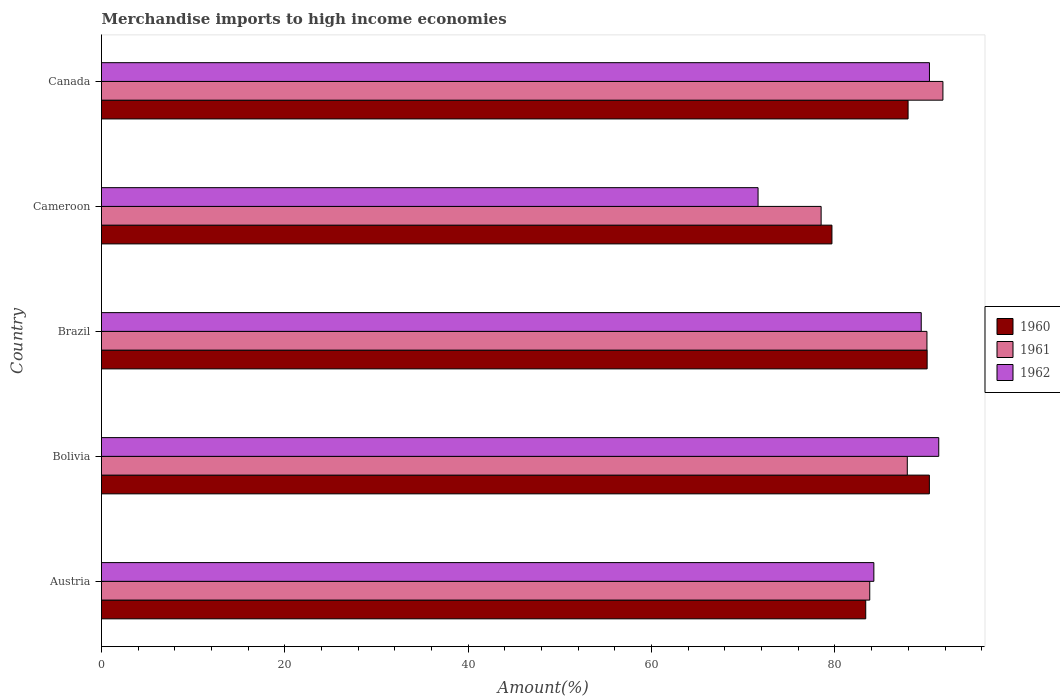How many bars are there on the 1st tick from the top?
Offer a terse response. 3. How many bars are there on the 4th tick from the bottom?
Provide a short and direct response. 3. What is the label of the 2nd group of bars from the top?
Provide a succinct answer. Cameroon. In how many cases, is the number of bars for a given country not equal to the number of legend labels?
Provide a short and direct response. 0. What is the percentage of amount earned from merchandise imports in 1962 in Canada?
Keep it short and to the point. 90.3. Across all countries, what is the maximum percentage of amount earned from merchandise imports in 1962?
Give a very brief answer. 91.32. Across all countries, what is the minimum percentage of amount earned from merchandise imports in 1961?
Offer a very short reply. 78.49. In which country was the percentage of amount earned from merchandise imports in 1962 maximum?
Offer a very short reply. Bolivia. In which country was the percentage of amount earned from merchandise imports in 1961 minimum?
Give a very brief answer. Cameroon. What is the total percentage of amount earned from merchandise imports in 1960 in the graph?
Ensure brevity in your answer.  431.34. What is the difference between the percentage of amount earned from merchandise imports in 1961 in Austria and that in Canada?
Your answer should be compact. -7.98. What is the difference between the percentage of amount earned from merchandise imports in 1960 in Bolivia and the percentage of amount earned from merchandise imports in 1961 in Austria?
Offer a very short reply. 6.5. What is the average percentage of amount earned from merchandise imports in 1962 per country?
Give a very brief answer. 85.38. What is the difference between the percentage of amount earned from merchandise imports in 1960 and percentage of amount earned from merchandise imports in 1962 in Brazil?
Your response must be concise. 0.64. In how many countries, is the percentage of amount earned from merchandise imports in 1962 greater than 76 %?
Make the answer very short. 4. What is the ratio of the percentage of amount earned from merchandise imports in 1962 in Cameroon to that in Canada?
Ensure brevity in your answer.  0.79. Is the percentage of amount earned from merchandise imports in 1961 in Austria less than that in Canada?
Provide a succinct answer. Yes. Is the difference between the percentage of amount earned from merchandise imports in 1960 in Brazil and Canada greater than the difference between the percentage of amount earned from merchandise imports in 1962 in Brazil and Canada?
Offer a very short reply. Yes. What is the difference between the highest and the second highest percentage of amount earned from merchandise imports in 1961?
Make the answer very short. 1.74. What is the difference between the highest and the lowest percentage of amount earned from merchandise imports in 1961?
Offer a terse response. 13.28. What does the 1st bar from the top in Bolivia represents?
Provide a succinct answer. 1962. How many bars are there?
Make the answer very short. 15. Are all the bars in the graph horizontal?
Keep it short and to the point. Yes. How many countries are there in the graph?
Your answer should be compact. 5. Are the values on the major ticks of X-axis written in scientific E-notation?
Offer a terse response. No. Does the graph contain any zero values?
Your response must be concise. No. Where does the legend appear in the graph?
Give a very brief answer. Center right. How are the legend labels stacked?
Offer a very short reply. Vertical. What is the title of the graph?
Ensure brevity in your answer.  Merchandise imports to high income economies. Does "1973" appear as one of the legend labels in the graph?
Offer a very short reply. No. What is the label or title of the X-axis?
Provide a short and direct response. Amount(%). What is the Amount(%) of 1960 in Austria?
Ensure brevity in your answer.  83.35. What is the Amount(%) in 1961 in Austria?
Your answer should be compact. 83.79. What is the Amount(%) of 1962 in Austria?
Offer a terse response. 84.24. What is the Amount(%) in 1960 in Bolivia?
Your answer should be very brief. 90.3. What is the Amount(%) of 1961 in Bolivia?
Ensure brevity in your answer.  87.89. What is the Amount(%) of 1962 in Bolivia?
Provide a short and direct response. 91.32. What is the Amount(%) in 1960 in Brazil?
Ensure brevity in your answer.  90.05. What is the Amount(%) in 1961 in Brazil?
Your response must be concise. 90.03. What is the Amount(%) of 1962 in Brazil?
Provide a succinct answer. 89.41. What is the Amount(%) of 1960 in Cameroon?
Provide a succinct answer. 79.67. What is the Amount(%) of 1961 in Cameroon?
Your answer should be very brief. 78.49. What is the Amount(%) in 1962 in Cameroon?
Offer a terse response. 71.61. What is the Amount(%) of 1960 in Canada?
Provide a short and direct response. 87.97. What is the Amount(%) in 1961 in Canada?
Your answer should be compact. 91.77. What is the Amount(%) of 1962 in Canada?
Your answer should be compact. 90.3. Across all countries, what is the maximum Amount(%) in 1960?
Your answer should be very brief. 90.3. Across all countries, what is the maximum Amount(%) of 1961?
Your answer should be compact. 91.77. Across all countries, what is the maximum Amount(%) in 1962?
Offer a very short reply. 91.32. Across all countries, what is the minimum Amount(%) of 1960?
Provide a short and direct response. 79.67. Across all countries, what is the minimum Amount(%) in 1961?
Offer a terse response. 78.49. Across all countries, what is the minimum Amount(%) in 1962?
Your answer should be very brief. 71.61. What is the total Amount(%) in 1960 in the graph?
Provide a short and direct response. 431.34. What is the total Amount(%) in 1961 in the graph?
Make the answer very short. 431.97. What is the total Amount(%) of 1962 in the graph?
Provide a short and direct response. 426.88. What is the difference between the Amount(%) in 1960 in Austria and that in Bolivia?
Keep it short and to the point. -6.94. What is the difference between the Amount(%) of 1961 in Austria and that in Bolivia?
Ensure brevity in your answer.  -4.1. What is the difference between the Amount(%) of 1962 in Austria and that in Bolivia?
Your answer should be compact. -7.08. What is the difference between the Amount(%) of 1960 in Austria and that in Brazil?
Offer a very short reply. -6.7. What is the difference between the Amount(%) in 1961 in Austria and that in Brazil?
Provide a succinct answer. -6.24. What is the difference between the Amount(%) of 1962 in Austria and that in Brazil?
Offer a terse response. -5.17. What is the difference between the Amount(%) in 1960 in Austria and that in Cameroon?
Provide a succinct answer. 3.69. What is the difference between the Amount(%) of 1961 in Austria and that in Cameroon?
Your response must be concise. 5.3. What is the difference between the Amount(%) in 1962 in Austria and that in Cameroon?
Your answer should be compact. 12.63. What is the difference between the Amount(%) of 1960 in Austria and that in Canada?
Provide a succinct answer. -4.62. What is the difference between the Amount(%) of 1961 in Austria and that in Canada?
Your response must be concise. -7.98. What is the difference between the Amount(%) in 1962 in Austria and that in Canada?
Your response must be concise. -6.06. What is the difference between the Amount(%) in 1960 in Bolivia and that in Brazil?
Your answer should be compact. 0.24. What is the difference between the Amount(%) in 1961 in Bolivia and that in Brazil?
Provide a succinct answer. -2.14. What is the difference between the Amount(%) in 1962 in Bolivia and that in Brazil?
Provide a short and direct response. 1.91. What is the difference between the Amount(%) of 1960 in Bolivia and that in Cameroon?
Your answer should be compact. 10.63. What is the difference between the Amount(%) in 1961 in Bolivia and that in Cameroon?
Provide a succinct answer. 9.4. What is the difference between the Amount(%) of 1962 in Bolivia and that in Cameroon?
Offer a very short reply. 19.71. What is the difference between the Amount(%) in 1960 in Bolivia and that in Canada?
Ensure brevity in your answer.  2.32. What is the difference between the Amount(%) of 1961 in Bolivia and that in Canada?
Your answer should be compact. -3.89. What is the difference between the Amount(%) of 1962 in Bolivia and that in Canada?
Keep it short and to the point. 1.01. What is the difference between the Amount(%) of 1960 in Brazil and that in Cameroon?
Offer a very short reply. 10.38. What is the difference between the Amount(%) in 1961 in Brazil and that in Cameroon?
Provide a short and direct response. 11.54. What is the difference between the Amount(%) of 1962 in Brazil and that in Cameroon?
Offer a terse response. 17.8. What is the difference between the Amount(%) in 1960 in Brazil and that in Canada?
Offer a very short reply. 2.08. What is the difference between the Amount(%) in 1961 in Brazil and that in Canada?
Keep it short and to the point. -1.74. What is the difference between the Amount(%) in 1962 in Brazil and that in Canada?
Your answer should be compact. -0.9. What is the difference between the Amount(%) of 1960 in Cameroon and that in Canada?
Ensure brevity in your answer.  -8.31. What is the difference between the Amount(%) in 1961 in Cameroon and that in Canada?
Offer a terse response. -13.28. What is the difference between the Amount(%) of 1962 in Cameroon and that in Canada?
Make the answer very short. -18.69. What is the difference between the Amount(%) of 1960 in Austria and the Amount(%) of 1961 in Bolivia?
Your answer should be compact. -4.53. What is the difference between the Amount(%) in 1960 in Austria and the Amount(%) in 1962 in Bolivia?
Provide a succinct answer. -7.96. What is the difference between the Amount(%) of 1961 in Austria and the Amount(%) of 1962 in Bolivia?
Your answer should be very brief. -7.53. What is the difference between the Amount(%) in 1960 in Austria and the Amount(%) in 1961 in Brazil?
Provide a succinct answer. -6.68. What is the difference between the Amount(%) in 1960 in Austria and the Amount(%) in 1962 in Brazil?
Ensure brevity in your answer.  -6.05. What is the difference between the Amount(%) of 1961 in Austria and the Amount(%) of 1962 in Brazil?
Keep it short and to the point. -5.62. What is the difference between the Amount(%) of 1960 in Austria and the Amount(%) of 1961 in Cameroon?
Offer a very short reply. 4.87. What is the difference between the Amount(%) in 1960 in Austria and the Amount(%) in 1962 in Cameroon?
Make the answer very short. 11.74. What is the difference between the Amount(%) in 1961 in Austria and the Amount(%) in 1962 in Cameroon?
Provide a short and direct response. 12.18. What is the difference between the Amount(%) in 1960 in Austria and the Amount(%) in 1961 in Canada?
Provide a succinct answer. -8.42. What is the difference between the Amount(%) of 1960 in Austria and the Amount(%) of 1962 in Canada?
Offer a very short reply. -6.95. What is the difference between the Amount(%) in 1961 in Austria and the Amount(%) in 1962 in Canada?
Your response must be concise. -6.51. What is the difference between the Amount(%) of 1960 in Bolivia and the Amount(%) of 1961 in Brazil?
Offer a terse response. 0.26. What is the difference between the Amount(%) of 1960 in Bolivia and the Amount(%) of 1962 in Brazil?
Ensure brevity in your answer.  0.89. What is the difference between the Amount(%) of 1961 in Bolivia and the Amount(%) of 1962 in Brazil?
Provide a succinct answer. -1.52. What is the difference between the Amount(%) of 1960 in Bolivia and the Amount(%) of 1961 in Cameroon?
Ensure brevity in your answer.  11.81. What is the difference between the Amount(%) of 1960 in Bolivia and the Amount(%) of 1962 in Cameroon?
Ensure brevity in your answer.  18.68. What is the difference between the Amount(%) of 1961 in Bolivia and the Amount(%) of 1962 in Cameroon?
Your answer should be compact. 16.28. What is the difference between the Amount(%) of 1960 in Bolivia and the Amount(%) of 1961 in Canada?
Provide a succinct answer. -1.48. What is the difference between the Amount(%) of 1960 in Bolivia and the Amount(%) of 1962 in Canada?
Your answer should be very brief. -0.01. What is the difference between the Amount(%) of 1961 in Bolivia and the Amount(%) of 1962 in Canada?
Make the answer very short. -2.42. What is the difference between the Amount(%) of 1960 in Brazil and the Amount(%) of 1961 in Cameroon?
Ensure brevity in your answer.  11.56. What is the difference between the Amount(%) in 1960 in Brazil and the Amount(%) in 1962 in Cameroon?
Your answer should be compact. 18.44. What is the difference between the Amount(%) in 1961 in Brazil and the Amount(%) in 1962 in Cameroon?
Ensure brevity in your answer.  18.42. What is the difference between the Amount(%) in 1960 in Brazil and the Amount(%) in 1961 in Canada?
Make the answer very short. -1.72. What is the difference between the Amount(%) of 1960 in Brazil and the Amount(%) of 1962 in Canada?
Your answer should be very brief. -0.25. What is the difference between the Amount(%) of 1961 in Brazil and the Amount(%) of 1962 in Canada?
Keep it short and to the point. -0.27. What is the difference between the Amount(%) of 1960 in Cameroon and the Amount(%) of 1961 in Canada?
Offer a very short reply. -12.11. What is the difference between the Amount(%) of 1960 in Cameroon and the Amount(%) of 1962 in Canada?
Keep it short and to the point. -10.64. What is the difference between the Amount(%) in 1961 in Cameroon and the Amount(%) in 1962 in Canada?
Your response must be concise. -11.82. What is the average Amount(%) of 1960 per country?
Keep it short and to the point. 86.27. What is the average Amount(%) in 1961 per country?
Ensure brevity in your answer.  86.39. What is the average Amount(%) in 1962 per country?
Your answer should be very brief. 85.38. What is the difference between the Amount(%) in 1960 and Amount(%) in 1961 in Austria?
Provide a short and direct response. -0.44. What is the difference between the Amount(%) of 1960 and Amount(%) of 1962 in Austria?
Offer a terse response. -0.89. What is the difference between the Amount(%) in 1961 and Amount(%) in 1962 in Austria?
Provide a short and direct response. -0.45. What is the difference between the Amount(%) of 1960 and Amount(%) of 1961 in Bolivia?
Give a very brief answer. 2.41. What is the difference between the Amount(%) of 1960 and Amount(%) of 1962 in Bolivia?
Your response must be concise. -1.02. What is the difference between the Amount(%) of 1961 and Amount(%) of 1962 in Bolivia?
Keep it short and to the point. -3.43. What is the difference between the Amount(%) in 1960 and Amount(%) in 1961 in Brazil?
Provide a short and direct response. 0.02. What is the difference between the Amount(%) in 1960 and Amount(%) in 1962 in Brazil?
Ensure brevity in your answer.  0.64. What is the difference between the Amount(%) of 1961 and Amount(%) of 1962 in Brazil?
Your answer should be very brief. 0.62. What is the difference between the Amount(%) of 1960 and Amount(%) of 1961 in Cameroon?
Offer a very short reply. 1.18. What is the difference between the Amount(%) of 1960 and Amount(%) of 1962 in Cameroon?
Keep it short and to the point. 8.06. What is the difference between the Amount(%) of 1961 and Amount(%) of 1962 in Cameroon?
Give a very brief answer. 6.88. What is the difference between the Amount(%) of 1960 and Amount(%) of 1961 in Canada?
Your answer should be very brief. -3.8. What is the difference between the Amount(%) in 1960 and Amount(%) in 1962 in Canada?
Keep it short and to the point. -2.33. What is the difference between the Amount(%) in 1961 and Amount(%) in 1962 in Canada?
Provide a short and direct response. 1.47. What is the ratio of the Amount(%) in 1960 in Austria to that in Bolivia?
Your response must be concise. 0.92. What is the ratio of the Amount(%) of 1961 in Austria to that in Bolivia?
Your response must be concise. 0.95. What is the ratio of the Amount(%) of 1962 in Austria to that in Bolivia?
Make the answer very short. 0.92. What is the ratio of the Amount(%) in 1960 in Austria to that in Brazil?
Offer a terse response. 0.93. What is the ratio of the Amount(%) of 1961 in Austria to that in Brazil?
Your answer should be compact. 0.93. What is the ratio of the Amount(%) of 1962 in Austria to that in Brazil?
Keep it short and to the point. 0.94. What is the ratio of the Amount(%) of 1960 in Austria to that in Cameroon?
Offer a very short reply. 1.05. What is the ratio of the Amount(%) in 1961 in Austria to that in Cameroon?
Your response must be concise. 1.07. What is the ratio of the Amount(%) in 1962 in Austria to that in Cameroon?
Keep it short and to the point. 1.18. What is the ratio of the Amount(%) of 1960 in Austria to that in Canada?
Give a very brief answer. 0.95. What is the ratio of the Amount(%) in 1962 in Austria to that in Canada?
Your answer should be compact. 0.93. What is the ratio of the Amount(%) of 1961 in Bolivia to that in Brazil?
Provide a short and direct response. 0.98. What is the ratio of the Amount(%) of 1962 in Bolivia to that in Brazil?
Provide a short and direct response. 1.02. What is the ratio of the Amount(%) of 1960 in Bolivia to that in Cameroon?
Your answer should be compact. 1.13. What is the ratio of the Amount(%) of 1961 in Bolivia to that in Cameroon?
Ensure brevity in your answer.  1.12. What is the ratio of the Amount(%) of 1962 in Bolivia to that in Cameroon?
Your response must be concise. 1.28. What is the ratio of the Amount(%) in 1960 in Bolivia to that in Canada?
Your response must be concise. 1.03. What is the ratio of the Amount(%) of 1961 in Bolivia to that in Canada?
Your response must be concise. 0.96. What is the ratio of the Amount(%) in 1962 in Bolivia to that in Canada?
Your answer should be compact. 1.01. What is the ratio of the Amount(%) in 1960 in Brazil to that in Cameroon?
Offer a very short reply. 1.13. What is the ratio of the Amount(%) of 1961 in Brazil to that in Cameroon?
Your response must be concise. 1.15. What is the ratio of the Amount(%) of 1962 in Brazil to that in Cameroon?
Ensure brevity in your answer.  1.25. What is the ratio of the Amount(%) in 1960 in Brazil to that in Canada?
Your answer should be compact. 1.02. What is the ratio of the Amount(%) of 1961 in Brazil to that in Canada?
Your response must be concise. 0.98. What is the ratio of the Amount(%) in 1960 in Cameroon to that in Canada?
Offer a terse response. 0.91. What is the ratio of the Amount(%) of 1961 in Cameroon to that in Canada?
Offer a terse response. 0.86. What is the ratio of the Amount(%) of 1962 in Cameroon to that in Canada?
Offer a very short reply. 0.79. What is the difference between the highest and the second highest Amount(%) in 1960?
Offer a very short reply. 0.24. What is the difference between the highest and the second highest Amount(%) of 1961?
Offer a terse response. 1.74. What is the difference between the highest and the second highest Amount(%) in 1962?
Ensure brevity in your answer.  1.01. What is the difference between the highest and the lowest Amount(%) of 1960?
Provide a short and direct response. 10.63. What is the difference between the highest and the lowest Amount(%) of 1961?
Your response must be concise. 13.28. What is the difference between the highest and the lowest Amount(%) of 1962?
Keep it short and to the point. 19.71. 